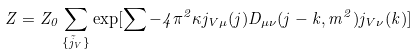Convert formula to latex. <formula><loc_0><loc_0><loc_500><loc_500>Z = Z _ { 0 } \sum _ { \{ \vec { j } _ { V } \} } \exp [ \sum - 4 \pi ^ { 2 } \kappa j _ { V \mu } ( j ) D _ { \mu \nu } ( j - k , m ^ { 2 } ) j _ { V \nu } ( k ) ]</formula> 